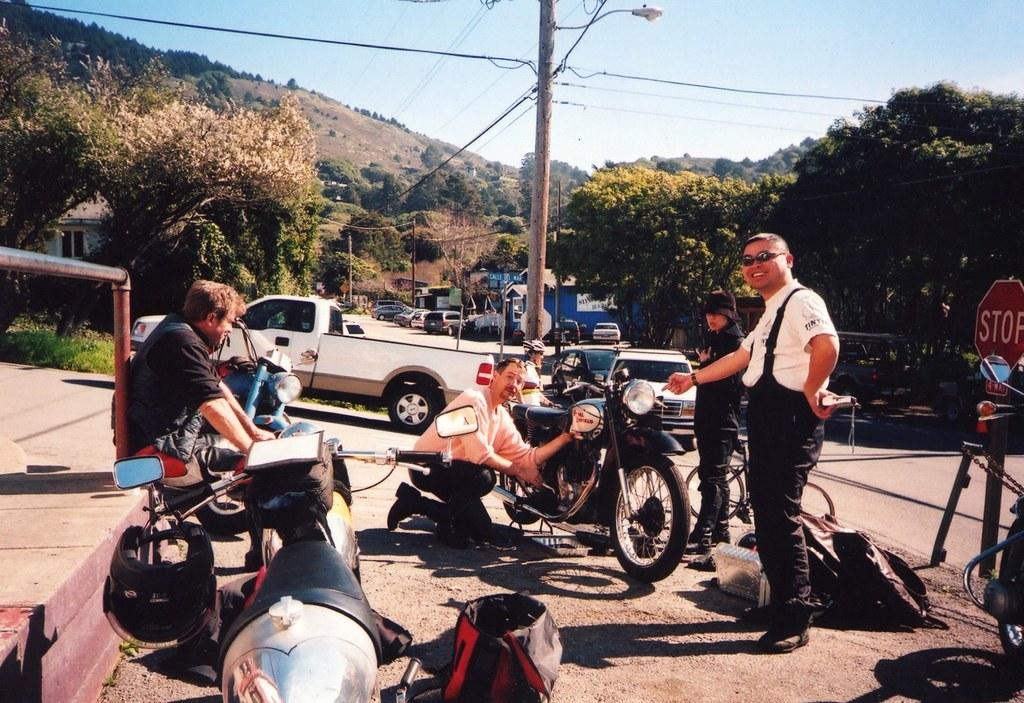What type of vehicles are present in the image? The men in the image are with motorcycles. Are there any other vehicles visible in the image? Yes, there are cars parked in the image. What can be seen in the background of the image? Trees are visible in the image. What structures are present in the image? There is a pole and a sign board in the image. Can you see a river flowing in the image? No, there is no river visible in the image. Are there any trucks present in the image? No, there are no trucks present in the image. 